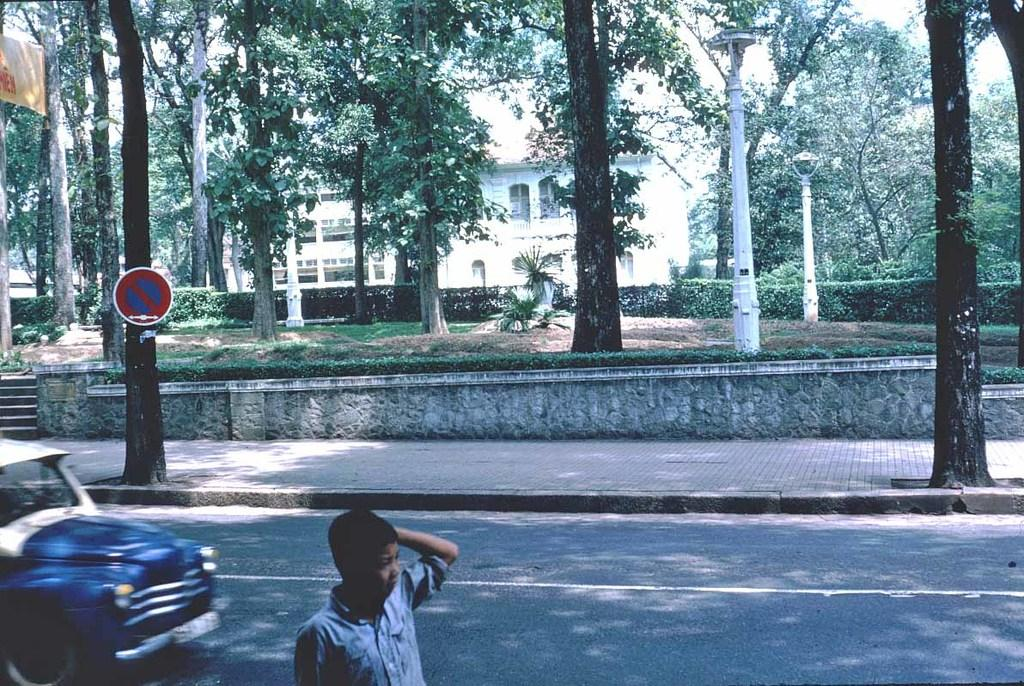What is present in the image along with the person? There is a vehicle in the image. What else can be seen in the image besides the person and vehicle? There is a sign board, trees, plants, buildings, and the sky visible in the image. How many people are gathered in the cemetery in the image? There is no cemetery present in the image, and therefore no crowd to count. 